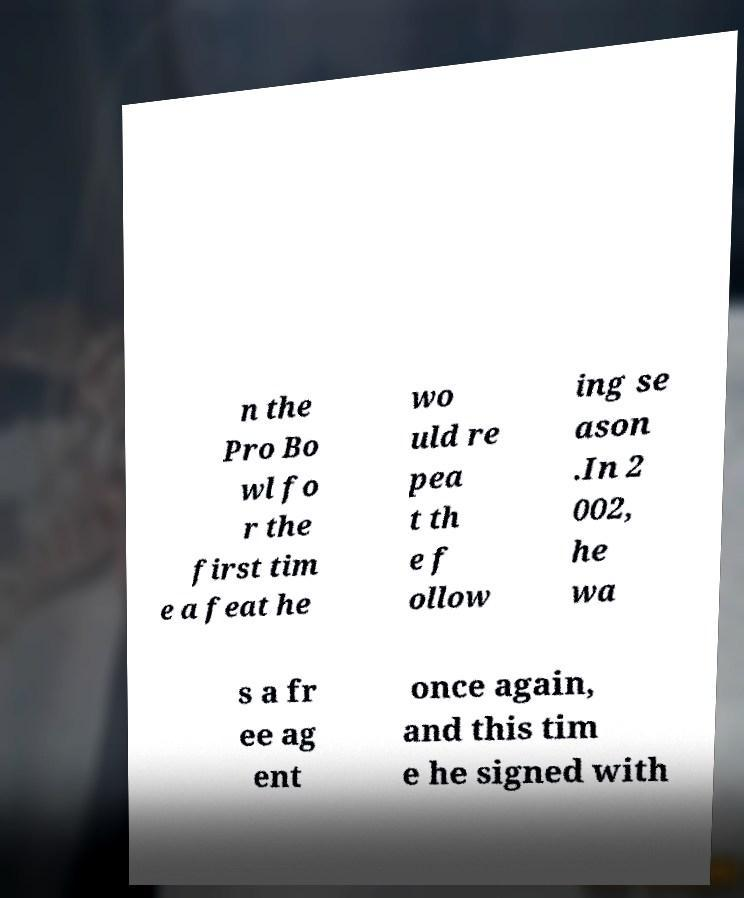Could you assist in decoding the text presented in this image and type it out clearly? n the Pro Bo wl fo r the first tim e a feat he wo uld re pea t th e f ollow ing se ason .In 2 002, he wa s a fr ee ag ent once again, and this tim e he signed with 